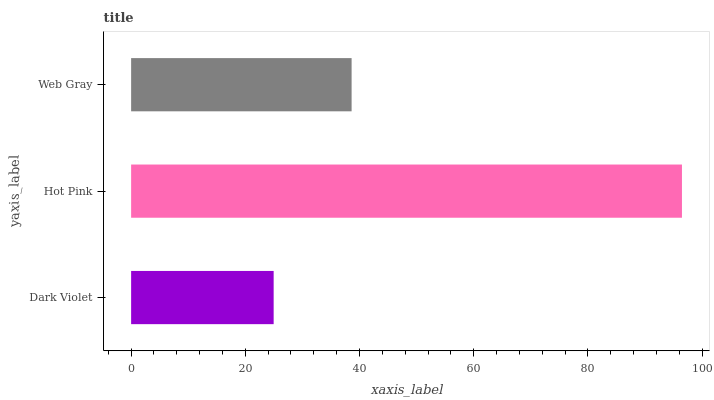Is Dark Violet the minimum?
Answer yes or no. Yes. Is Hot Pink the maximum?
Answer yes or no. Yes. Is Web Gray the minimum?
Answer yes or no. No. Is Web Gray the maximum?
Answer yes or no. No. Is Hot Pink greater than Web Gray?
Answer yes or no. Yes. Is Web Gray less than Hot Pink?
Answer yes or no. Yes. Is Web Gray greater than Hot Pink?
Answer yes or no. No. Is Hot Pink less than Web Gray?
Answer yes or no. No. Is Web Gray the high median?
Answer yes or no. Yes. Is Web Gray the low median?
Answer yes or no. Yes. Is Hot Pink the high median?
Answer yes or no. No. Is Hot Pink the low median?
Answer yes or no. No. 